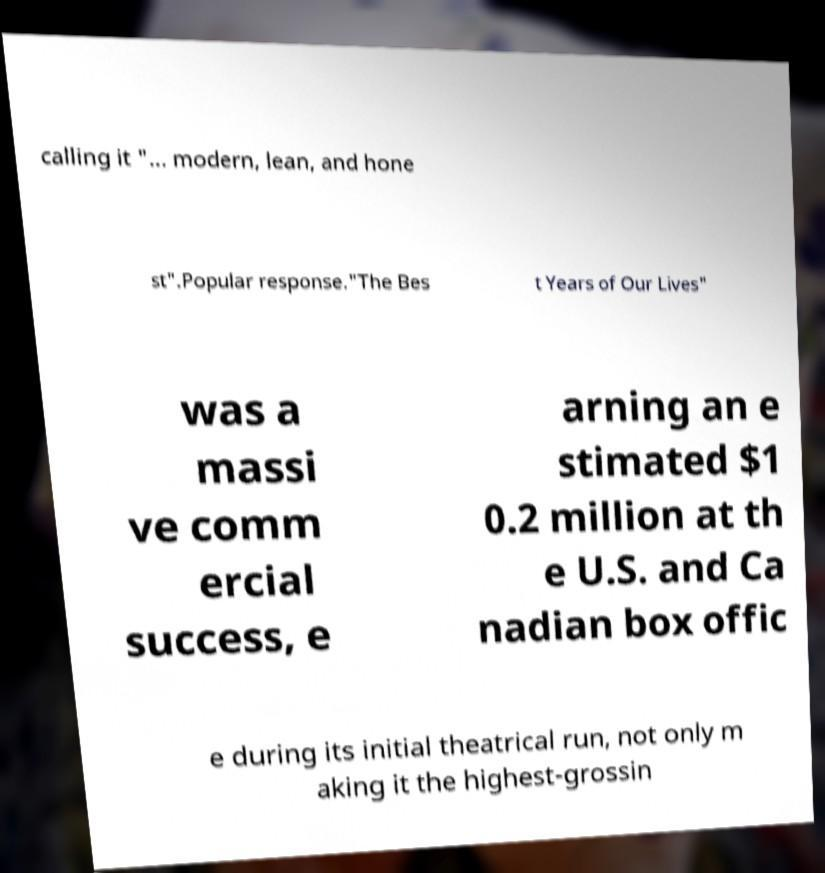I need the written content from this picture converted into text. Can you do that? calling it "... modern, lean, and hone st".Popular response."The Bes t Years of Our Lives" was a massi ve comm ercial success, e arning an e stimated $1 0.2 million at th e U.S. and Ca nadian box offic e during its initial theatrical run, not only m aking it the highest-grossin 